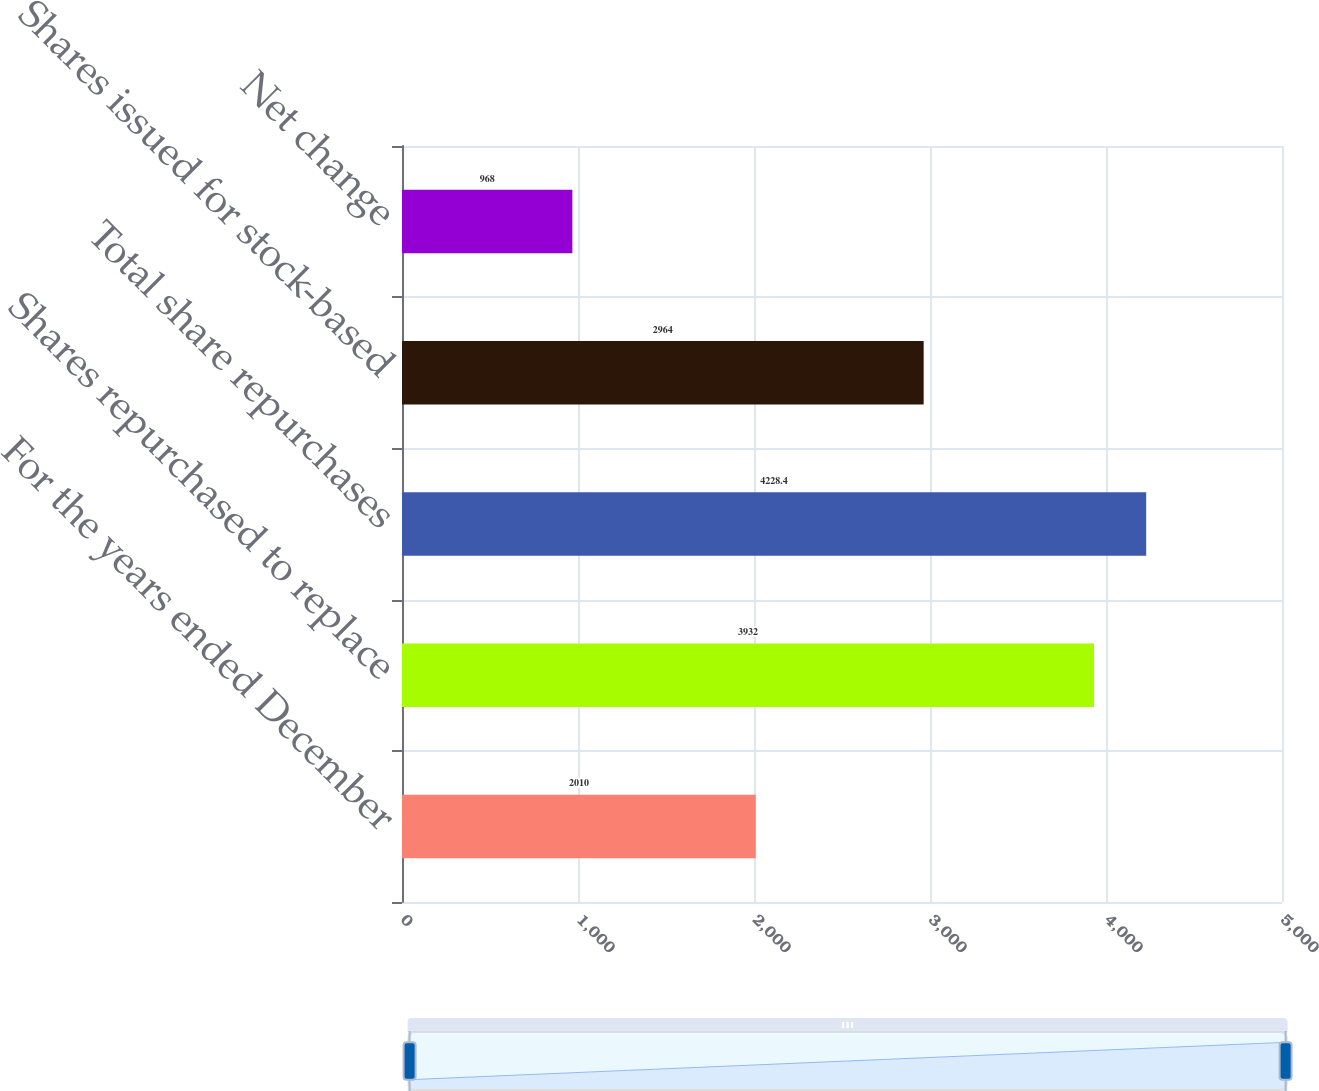Convert chart to OTSL. <chart><loc_0><loc_0><loc_500><loc_500><bar_chart><fcel>For the years ended December<fcel>Shares repurchased to replace<fcel>Total share repurchases<fcel>Shares issued for stock-based<fcel>Net change<nl><fcel>2010<fcel>3932<fcel>4228.4<fcel>2964<fcel>968<nl></chart> 